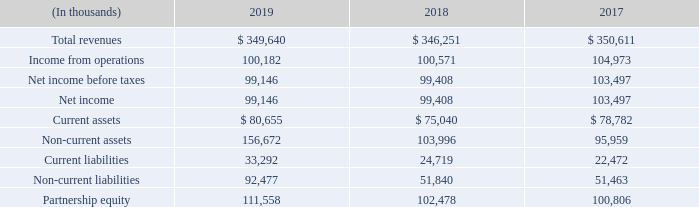Equity Method We own 20.51%of GTE Mobilnet of Texas RSA #17 Limited Partnership (“RSA #17”), 16.67% of Pennsylvania RSA 6(I) Limited Partnership (“RSA 6(I)”) and 23.67% of Pennsylvania RSA 6(II) Limited Partnership (“RSA 6(II)”). RSA #17 provides cellular service to a limited rural area in Texas.
RSA 6(I) and RSA 6(II) provide cellular service in and around our Pennsylvania service territory. Because we have significant influence over the operating and financial policies of these three entities, we account for the investments using the equity method. In connection with the adoption of ASC 606 by our equity method partnerships, the value of our combined partnership interests increased $1.8 million, which is reflected in the cumulative effect adjustment to retained earnings during the year ended December 31, 2018.
In 2019, 2018 and 2017, we received cash distributions from these partnerships totaling $19.0 million, $21.8 million and $17.2 million, respectively. The carrying value of the investments exceeds the underlying equity in net assets of the partnerships by $32.8 million as of December 31, 2019 and 2018.
The combined results of operations and financial position of our three equity investments in the cellular limited partnerships are summarized below:
What is the company's ownership of GTE Mobilnet of Texas RSA#17? 20.51%. What was the cash distribution received in 2019 from partnerships? $19.0 million. What is the Total revenues for 2019?
Answer scale should be: thousand. $ 349,640. What was the increase / (decrease) in the total revenues from 2018 to 2019?
Answer scale should be: thousand. 349,640 - 346,251
Answer: 3389. What was the average income from operations for 2017-2019?
Answer scale should be: thousand. (100,182 + 100,571 + 104,973) / 3
Answer: 101908.67. What was the percentage increase / (decrease) in the net income from 2018 to 2019?
Answer scale should be: percent. 99,146 / 99,408 - 1
Answer: -0.26. 